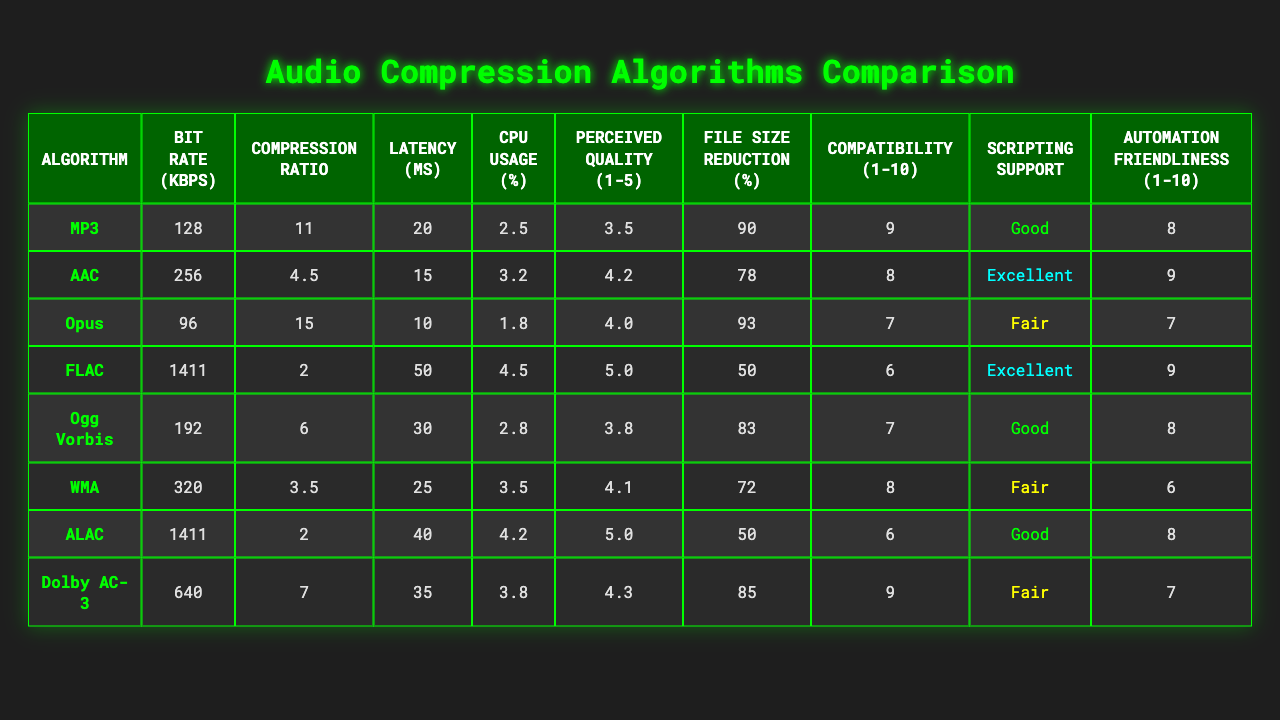What is the compression ratio of the Opus algorithm? The table shows that the compression ratio for the Opus algorithm is 15.
Answer: 15 Which algorithm has the lowest CPU usage percentage? By examining the CPU usage percentages, Opus has the lowest value at 1.8%.
Answer: 1.8% What is the average bit rate of the audio compression algorithms listed? To find the average bit rate, add all bit rates (128 + 256 + 96 + 1411 + 192 + 320 + 1411 + 640 = 3054) and divide by the number of algorithms (8), resulting in 3054 / 8 = 381.75.
Answer: 381.75 Is the perceived quality of FLAC higher than that of AAC? The perceived quality for FLAC is 5.0 and for AAC it is 4.2, thus FLAC's quality is indeed higher.
Answer: Yes Which algorithm has the highest file size reduction percentage? Looking at the file size reduction percentages, Opus leads with 93%.
Answer: 93% What is the difference in latency between MP3 and AAC? The latency for MP3 is 20 ms and for AAC is 15 ms. Subtracting these values gives 20 - 15 = 5 ms.
Answer: 5 ms Which algorithm has the worst compatibility score? The table shows that both FLAC and ALAC have a compatibility score of 6, which is the lowest among all algorithms.
Answer: 6 What is the perceived quality range for the compression algorithms? The highest perceived quality is 5.0 (FLAC and ALAC) and the lowest is 3.5 (MP3), so the range is 5.0 - 3.5 = 1.5.
Answer: 1.5 Is AAC more automation-friendly than FLAC? The automation friendliness score for AAC is 9, while for FLAC it is 9 as well, they are equal with no difference.
Answer: No How does the CPU usage of Dolby AC-3 compare to that of WMA? Dolby AC-3 has a CPU usage of 3.8%, while WMA is at 3.5%, making Dolby AC-3 slightly higher.
Answer: Yes, Dolby AC-3 is higher 